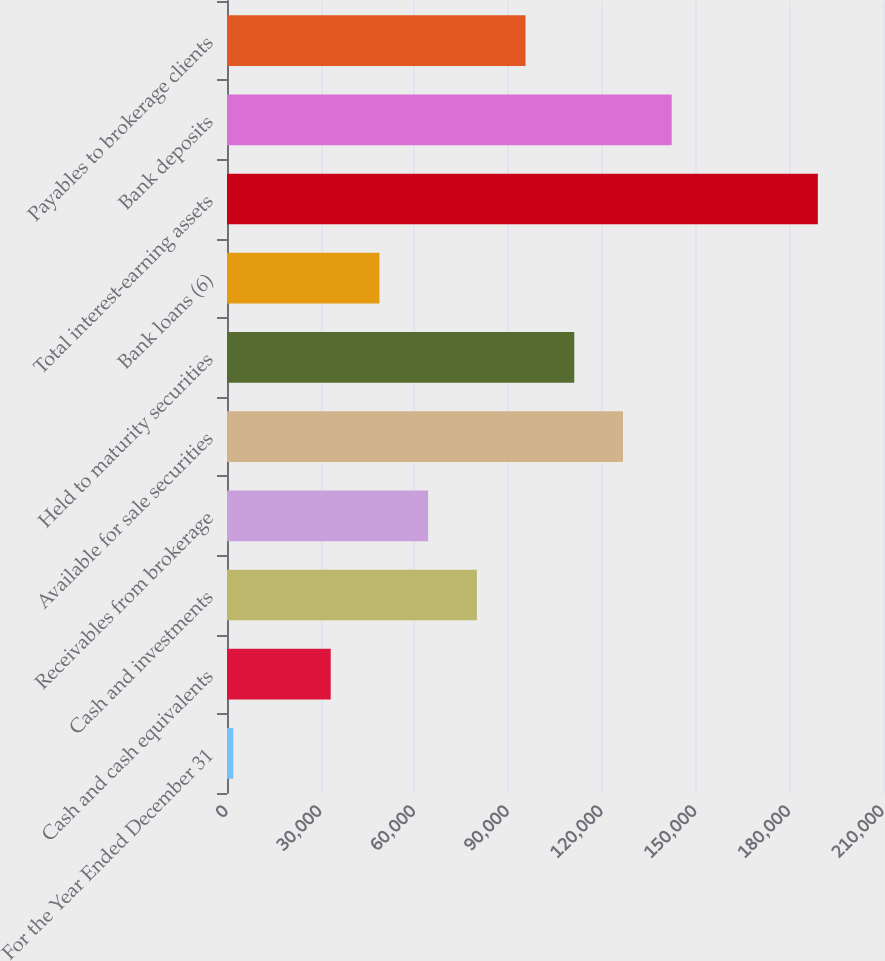<chart> <loc_0><loc_0><loc_500><loc_500><bar_chart><fcel>For the Year Ended December 31<fcel>Cash and cash equivalents<fcel>Cash and investments<fcel>Receivables from brokerage<fcel>Available for sale securities<fcel>Held to maturity securities<fcel>Bank loans (6)<fcel>Total interest-earning assets<fcel>Bank deposits<fcel>Payables to brokerage clients<nl><fcel>2015<fcel>33202.4<fcel>79983.5<fcel>64389.8<fcel>126765<fcel>111171<fcel>48796.1<fcel>189139<fcel>142358<fcel>95577.2<nl></chart> 